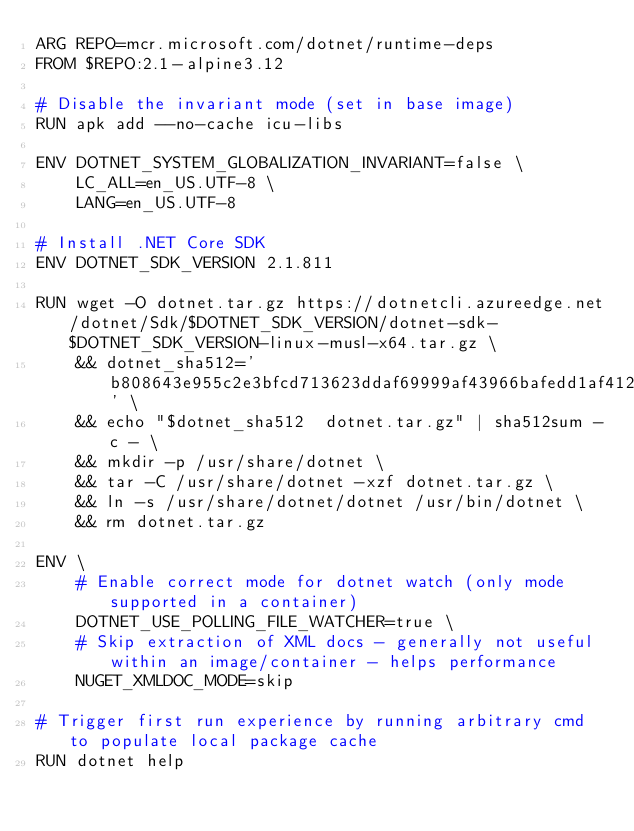<code> <loc_0><loc_0><loc_500><loc_500><_Dockerfile_>ARG REPO=mcr.microsoft.com/dotnet/runtime-deps
FROM $REPO:2.1-alpine3.12

# Disable the invariant mode (set in base image)
RUN apk add --no-cache icu-libs

ENV DOTNET_SYSTEM_GLOBALIZATION_INVARIANT=false \
    LC_ALL=en_US.UTF-8 \
    LANG=en_US.UTF-8

# Install .NET Core SDK
ENV DOTNET_SDK_VERSION 2.1.811

RUN wget -O dotnet.tar.gz https://dotnetcli.azureedge.net/dotnet/Sdk/$DOTNET_SDK_VERSION/dotnet-sdk-$DOTNET_SDK_VERSION-linux-musl-x64.tar.gz \
    && dotnet_sha512='b808643e955c2e3bfcd713623ddaf69999af43966bafedd1af4124e7faa1cebbfefe891d2e540643754c451018ba52d2afca8c27b6d598ceb01a07040864e807' \
    && echo "$dotnet_sha512  dotnet.tar.gz" | sha512sum -c - \
    && mkdir -p /usr/share/dotnet \
    && tar -C /usr/share/dotnet -xzf dotnet.tar.gz \
    && ln -s /usr/share/dotnet/dotnet /usr/bin/dotnet \
    && rm dotnet.tar.gz

ENV \
    # Enable correct mode for dotnet watch (only mode supported in a container)
    DOTNET_USE_POLLING_FILE_WATCHER=true \ 
    # Skip extraction of XML docs - generally not useful within an image/container - helps performance
    NUGET_XMLDOC_MODE=skip

# Trigger first run experience by running arbitrary cmd to populate local package cache
RUN dotnet help
</code> 